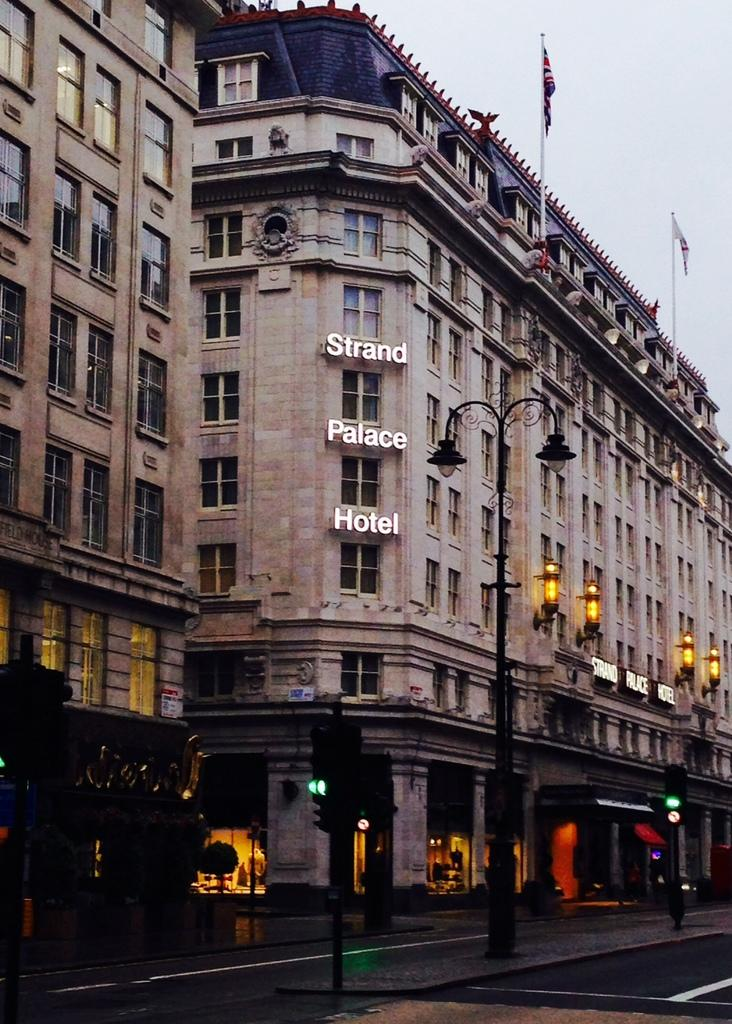What type of structures are present in the image? There are buildings in the image. What features can be observed on the buildings? The buildings have windows and doors. What type of establishments can be found in the buildings? There are stores in the buildings. Is there any text visible on the buildings? Yes, there is text on the buildings. What additional objects can be seen in the image? There are flags, poles, lights, and signal poles in the image. What is the primary mode of transportation in the image? There is a road in the image, which suggests that vehicles might be used for transportation. What part of the natural environment is visible in the image? The sky is visible in the image. How does the statement help the person in the image? There is no statement or person present in the image, so it is not possible to determine how a statement might help someone. 